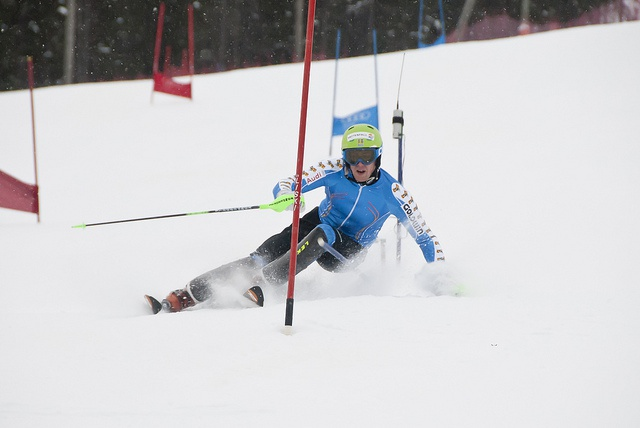Describe the objects in this image and their specific colors. I can see people in black, lightgray, blue, gray, and darkgray tones and skis in black, lightgray, gray, and darkgray tones in this image. 